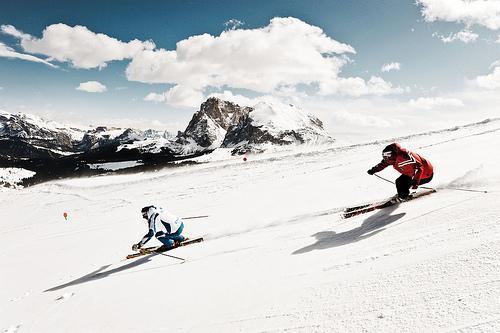How many people in the photo?
Give a very brief answer. 2. 